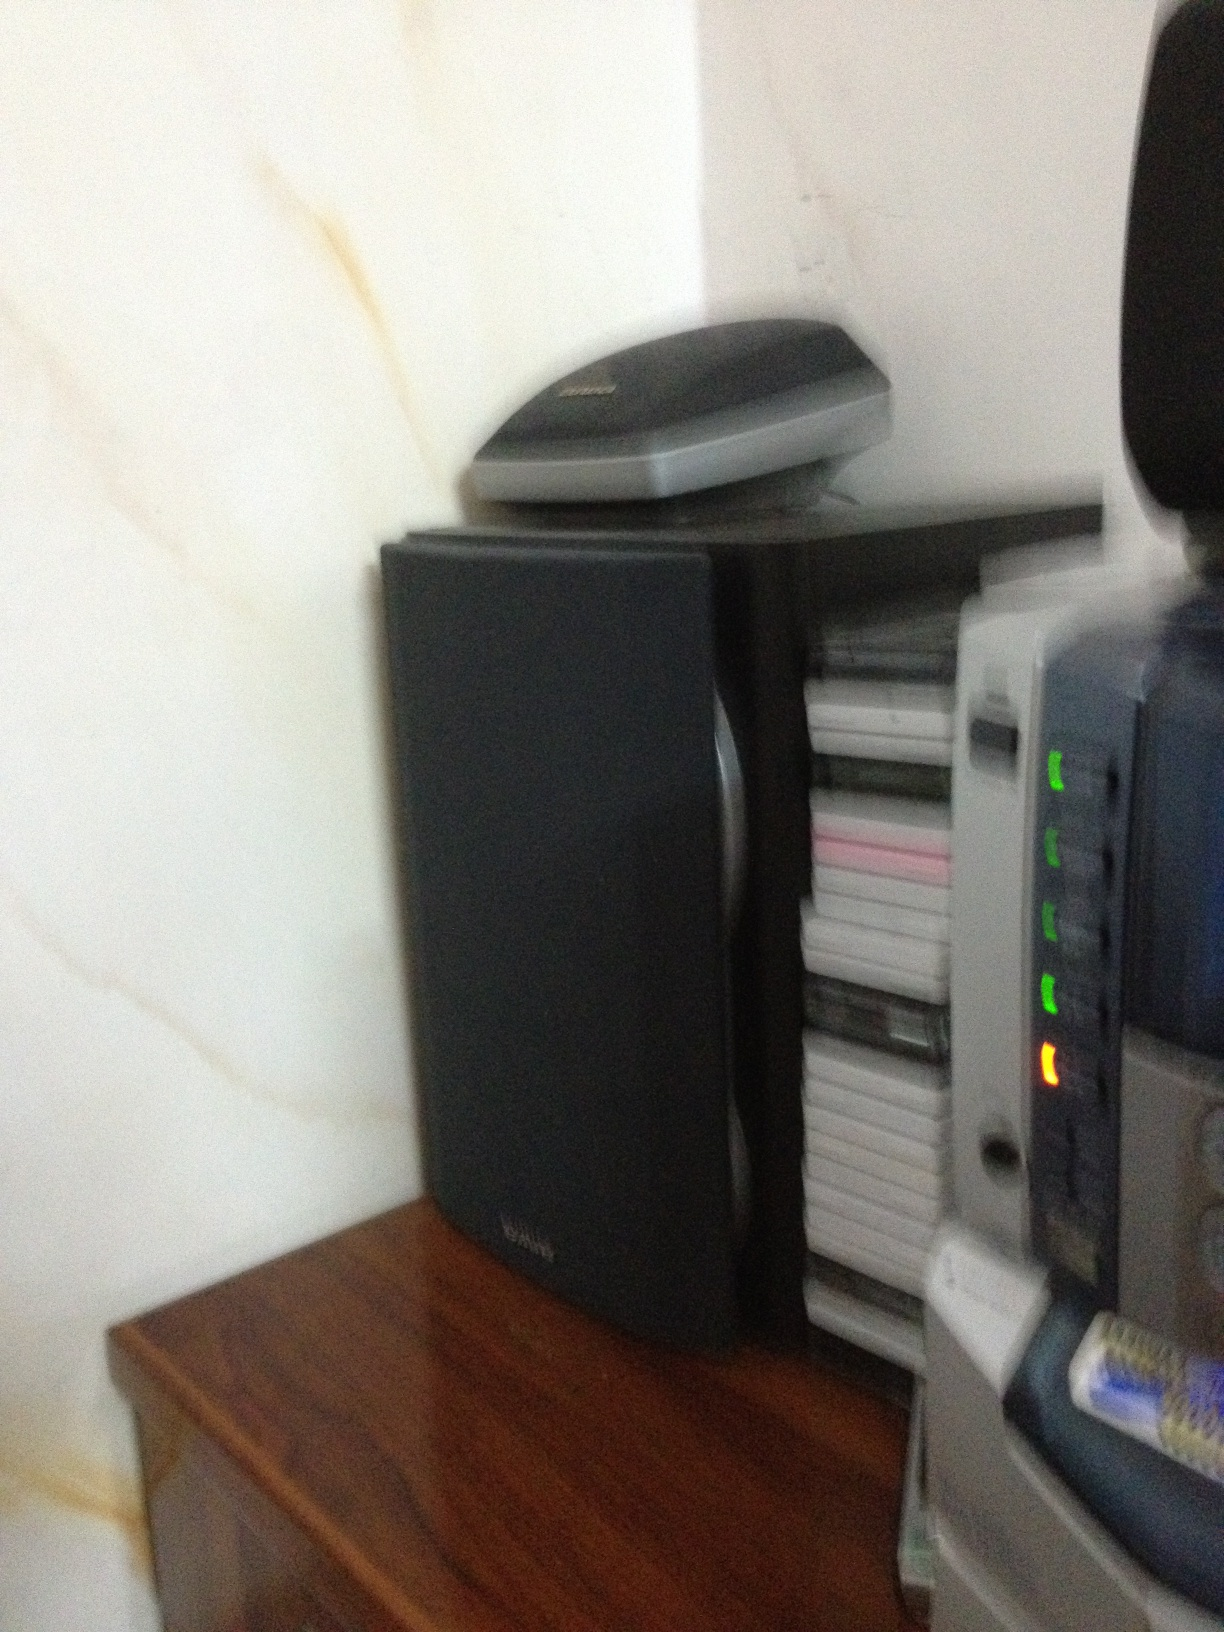What scenario could involve these devices being used together harmoniously? In a home office or study room, these devices could be used together in a multimedia and productivity setup. The speaker enhances the audio experience for video conferences, music, or videos. The stack of CDs or DVDs provides the user with physical media options for backups, data retrieval, or entertainment. The scanner allows digitization of documents, photos, and other physical materials for easier storage and access. Meanwhile, the central device with indicator lights could serve as a printer or a control panel for managing various home office devices, ensuring everything works seamlessly together.  Can you imagine a quick scenario involving these items? Sure! A user might be preparing for an important presentation. The speaker plays background music to set a focused atmosphere. The user scans some critical documents to include in the presentation, while accessing older reports from the CDs or DVDs. The central device ensures that all connected equipment runs smoothly without any interruptions. 